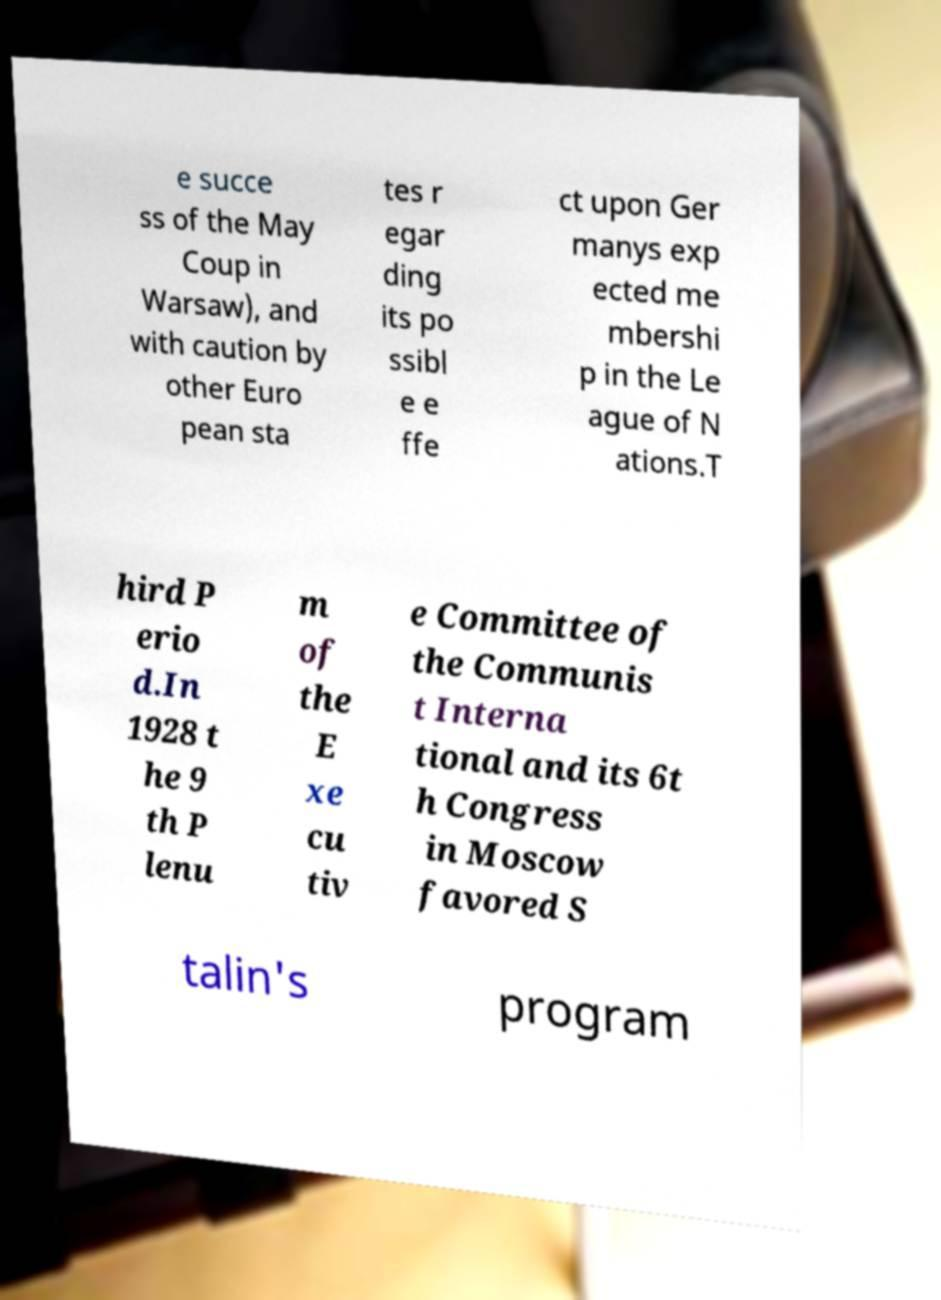For documentation purposes, I need the text within this image transcribed. Could you provide that? e succe ss of the May Coup in Warsaw), and with caution by other Euro pean sta tes r egar ding its po ssibl e e ffe ct upon Ger manys exp ected me mbershi p in the Le ague of N ations.T hird P erio d.In 1928 t he 9 th P lenu m of the E xe cu tiv e Committee of the Communis t Interna tional and its 6t h Congress in Moscow favored S talin's program 